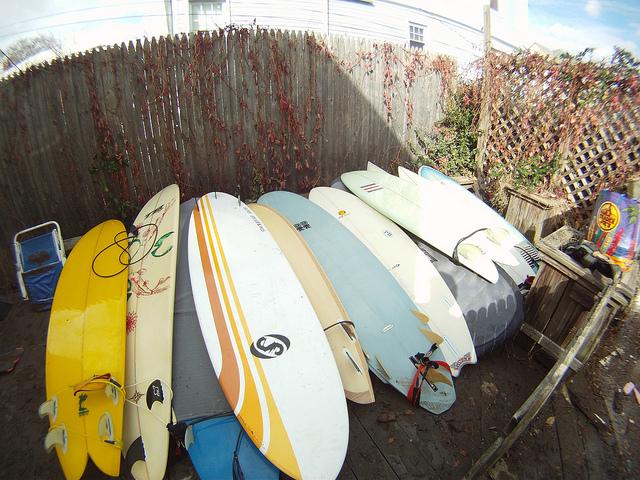Are there any green surfboards?
Short answer required. No. How many surfboards?
Give a very brief answer. 9. Are there any red surfboards?
Concise answer only. No. 